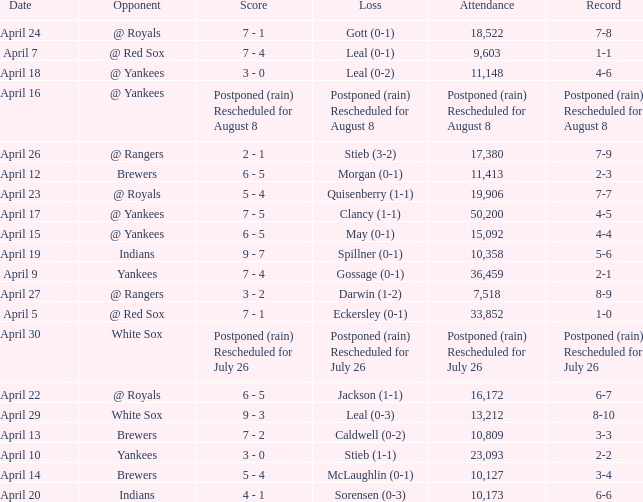What was the score of the game attended by 50,200? 7 - 5. 